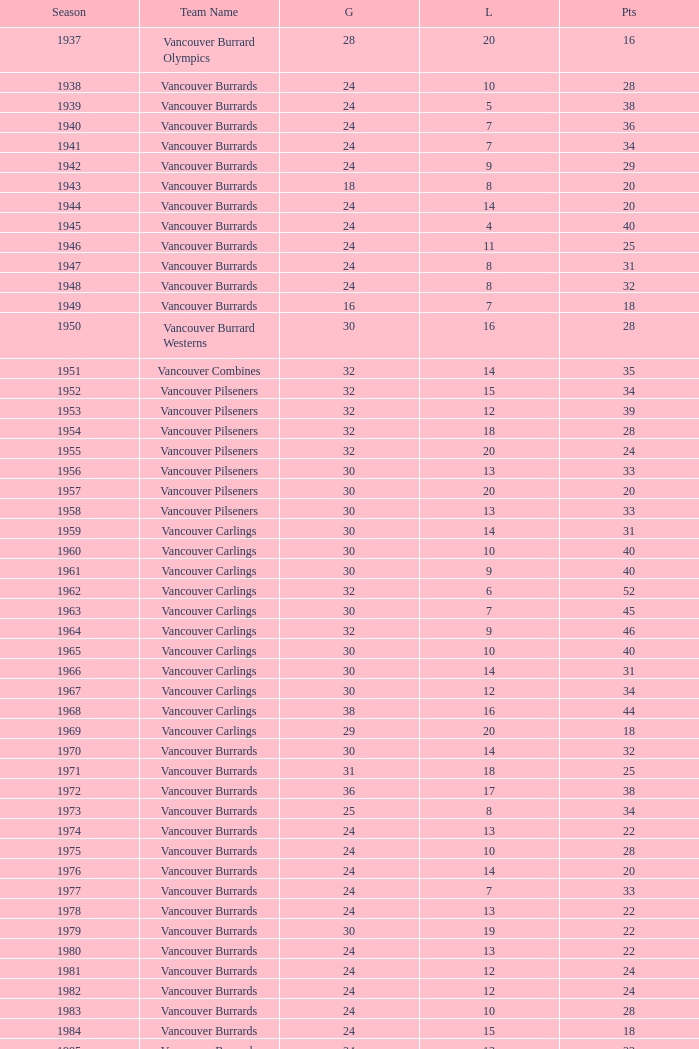What's the total losses for the vancouver burrards in the 1947 season with fewer than 24 games? 0.0. 